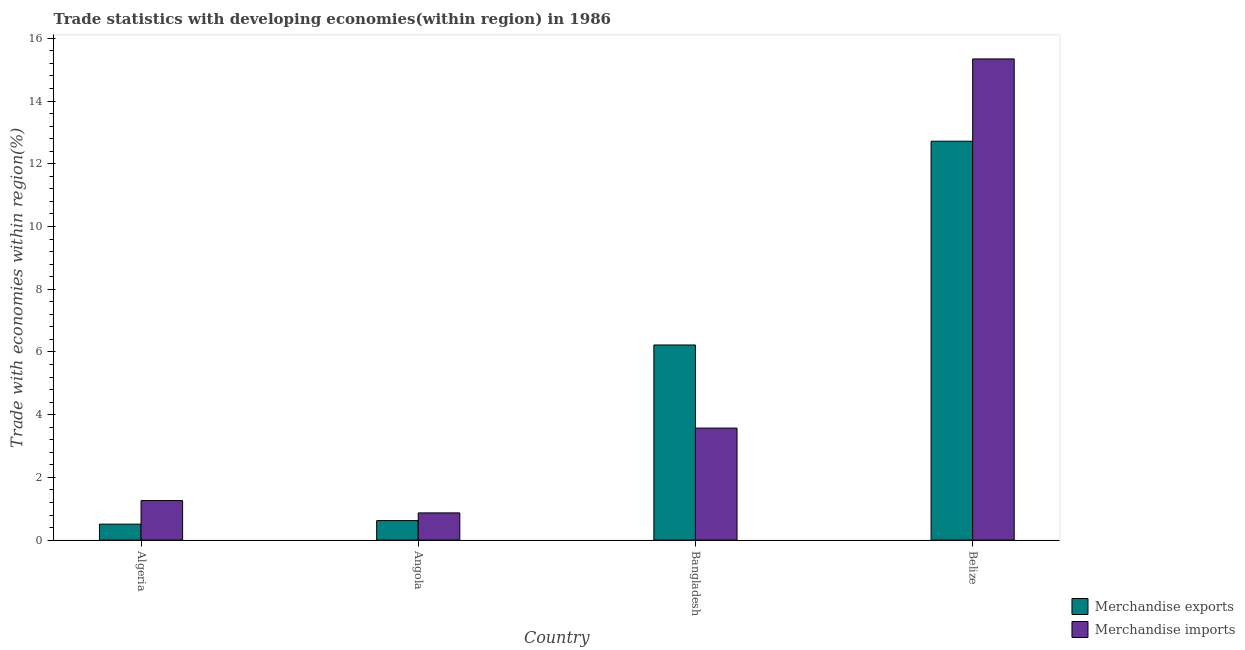How many groups of bars are there?
Give a very brief answer. 4. Are the number of bars per tick equal to the number of legend labels?
Your answer should be compact. Yes. Are the number of bars on each tick of the X-axis equal?
Your answer should be very brief. Yes. How many bars are there on the 2nd tick from the right?
Make the answer very short. 2. What is the merchandise imports in Belize?
Provide a succinct answer. 15.34. Across all countries, what is the maximum merchandise imports?
Your response must be concise. 15.34. Across all countries, what is the minimum merchandise exports?
Your answer should be very brief. 0.51. In which country was the merchandise exports maximum?
Your answer should be very brief. Belize. In which country was the merchandise imports minimum?
Your answer should be compact. Angola. What is the total merchandise exports in the graph?
Offer a terse response. 20.07. What is the difference between the merchandise imports in Angola and that in Bangladesh?
Your answer should be compact. -2.7. What is the difference between the merchandise exports in Angola and the merchandise imports in Algeria?
Provide a succinct answer. -0.64. What is the average merchandise imports per country?
Your response must be concise. 5.26. What is the difference between the merchandise exports and merchandise imports in Algeria?
Your response must be concise. -0.75. In how many countries, is the merchandise exports greater than 7.2 %?
Your response must be concise. 1. What is the ratio of the merchandise imports in Algeria to that in Belize?
Your answer should be compact. 0.08. Is the difference between the merchandise imports in Bangladesh and Belize greater than the difference between the merchandise exports in Bangladesh and Belize?
Offer a very short reply. No. What is the difference between the highest and the second highest merchandise imports?
Your answer should be compact. 11.77. What is the difference between the highest and the lowest merchandise exports?
Your answer should be very brief. 12.21. In how many countries, is the merchandise exports greater than the average merchandise exports taken over all countries?
Ensure brevity in your answer.  2. How many bars are there?
Keep it short and to the point. 8. Does the graph contain grids?
Give a very brief answer. No. How many legend labels are there?
Keep it short and to the point. 2. What is the title of the graph?
Keep it short and to the point. Trade statistics with developing economies(within region) in 1986. Does "Commercial service imports" appear as one of the legend labels in the graph?
Your answer should be compact. No. What is the label or title of the Y-axis?
Your response must be concise. Trade with economies within region(%). What is the Trade with economies within region(%) in Merchandise exports in Algeria?
Keep it short and to the point. 0.51. What is the Trade with economies within region(%) in Merchandise imports in Algeria?
Provide a succinct answer. 1.26. What is the Trade with economies within region(%) of Merchandise exports in Angola?
Provide a short and direct response. 0.62. What is the Trade with economies within region(%) in Merchandise imports in Angola?
Offer a terse response. 0.87. What is the Trade with economies within region(%) in Merchandise exports in Bangladesh?
Provide a short and direct response. 6.22. What is the Trade with economies within region(%) in Merchandise imports in Bangladesh?
Provide a short and direct response. 3.57. What is the Trade with economies within region(%) of Merchandise exports in Belize?
Your response must be concise. 12.72. What is the Trade with economies within region(%) in Merchandise imports in Belize?
Provide a short and direct response. 15.34. Across all countries, what is the maximum Trade with economies within region(%) in Merchandise exports?
Your response must be concise. 12.72. Across all countries, what is the maximum Trade with economies within region(%) in Merchandise imports?
Your answer should be very brief. 15.34. Across all countries, what is the minimum Trade with economies within region(%) of Merchandise exports?
Provide a short and direct response. 0.51. Across all countries, what is the minimum Trade with economies within region(%) of Merchandise imports?
Offer a very short reply. 0.87. What is the total Trade with economies within region(%) in Merchandise exports in the graph?
Your answer should be very brief. 20.07. What is the total Trade with economies within region(%) of Merchandise imports in the graph?
Give a very brief answer. 21.04. What is the difference between the Trade with economies within region(%) in Merchandise exports in Algeria and that in Angola?
Give a very brief answer. -0.11. What is the difference between the Trade with economies within region(%) of Merchandise imports in Algeria and that in Angola?
Keep it short and to the point. 0.39. What is the difference between the Trade with economies within region(%) of Merchandise exports in Algeria and that in Bangladesh?
Ensure brevity in your answer.  -5.71. What is the difference between the Trade with economies within region(%) of Merchandise imports in Algeria and that in Bangladesh?
Provide a succinct answer. -2.31. What is the difference between the Trade with economies within region(%) of Merchandise exports in Algeria and that in Belize?
Give a very brief answer. -12.21. What is the difference between the Trade with economies within region(%) in Merchandise imports in Algeria and that in Belize?
Your answer should be compact. -14.08. What is the difference between the Trade with economies within region(%) in Merchandise exports in Angola and that in Bangladesh?
Provide a short and direct response. -5.6. What is the difference between the Trade with economies within region(%) in Merchandise imports in Angola and that in Bangladesh?
Provide a short and direct response. -2.7. What is the difference between the Trade with economies within region(%) of Merchandise exports in Angola and that in Belize?
Give a very brief answer. -12.1. What is the difference between the Trade with economies within region(%) of Merchandise imports in Angola and that in Belize?
Give a very brief answer. -14.48. What is the difference between the Trade with economies within region(%) in Merchandise exports in Bangladesh and that in Belize?
Give a very brief answer. -6.5. What is the difference between the Trade with economies within region(%) in Merchandise imports in Bangladesh and that in Belize?
Provide a short and direct response. -11.77. What is the difference between the Trade with economies within region(%) of Merchandise exports in Algeria and the Trade with economies within region(%) of Merchandise imports in Angola?
Provide a succinct answer. -0.36. What is the difference between the Trade with economies within region(%) of Merchandise exports in Algeria and the Trade with economies within region(%) of Merchandise imports in Bangladesh?
Offer a very short reply. -3.06. What is the difference between the Trade with economies within region(%) of Merchandise exports in Algeria and the Trade with economies within region(%) of Merchandise imports in Belize?
Keep it short and to the point. -14.84. What is the difference between the Trade with economies within region(%) in Merchandise exports in Angola and the Trade with economies within region(%) in Merchandise imports in Bangladesh?
Your answer should be compact. -2.95. What is the difference between the Trade with economies within region(%) of Merchandise exports in Angola and the Trade with economies within region(%) of Merchandise imports in Belize?
Ensure brevity in your answer.  -14.72. What is the difference between the Trade with economies within region(%) in Merchandise exports in Bangladesh and the Trade with economies within region(%) in Merchandise imports in Belize?
Make the answer very short. -9.12. What is the average Trade with economies within region(%) of Merchandise exports per country?
Give a very brief answer. 5.02. What is the average Trade with economies within region(%) of Merchandise imports per country?
Your answer should be compact. 5.26. What is the difference between the Trade with economies within region(%) of Merchandise exports and Trade with economies within region(%) of Merchandise imports in Algeria?
Your answer should be very brief. -0.75. What is the difference between the Trade with economies within region(%) in Merchandise exports and Trade with economies within region(%) in Merchandise imports in Angola?
Ensure brevity in your answer.  -0.25. What is the difference between the Trade with economies within region(%) of Merchandise exports and Trade with economies within region(%) of Merchandise imports in Bangladesh?
Give a very brief answer. 2.65. What is the difference between the Trade with economies within region(%) of Merchandise exports and Trade with economies within region(%) of Merchandise imports in Belize?
Offer a terse response. -2.62. What is the ratio of the Trade with economies within region(%) of Merchandise exports in Algeria to that in Angola?
Offer a terse response. 0.82. What is the ratio of the Trade with economies within region(%) in Merchandise imports in Algeria to that in Angola?
Provide a succinct answer. 1.45. What is the ratio of the Trade with economies within region(%) of Merchandise exports in Algeria to that in Bangladesh?
Provide a succinct answer. 0.08. What is the ratio of the Trade with economies within region(%) in Merchandise imports in Algeria to that in Bangladesh?
Provide a succinct answer. 0.35. What is the ratio of the Trade with economies within region(%) in Merchandise imports in Algeria to that in Belize?
Offer a terse response. 0.08. What is the ratio of the Trade with economies within region(%) in Merchandise exports in Angola to that in Bangladesh?
Provide a succinct answer. 0.1. What is the ratio of the Trade with economies within region(%) of Merchandise imports in Angola to that in Bangladesh?
Provide a succinct answer. 0.24. What is the ratio of the Trade with economies within region(%) of Merchandise exports in Angola to that in Belize?
Your response must be concise. 0.05. What is the ratio of the Trade with economies within region(%) in Merchandise imports in Angola to that in Belize?
Ensure brevity in your answer.  0.06. What is the ratio of the Trade with economies within region(%) in Merchandise exports in Bangladesh to that in Belize?
Give a very brief answer. 0.49. What is the ratio of the Trade with economies within region(%) in Merchandise imports in Bangladesh to that in Belize?
Your answer should be compact. 0.23. What is the difference between the highest and the second highest Trade with economies within region(%) of Merchandise exports?
Offer a very short reply. 6.5. What is the difference between the highest and the second highest Trade with economies within region(%) in Merchandise imports?
Provide a succinct answer. 11.77. What is the difference between the highest and the lowest Trade with economies within region(%) of Merchandise exports?
Provide a short and direct response. 12.21. What is the difference between the highest and the lowest Trade with economies within region(%) of Merchandise imports?
Keep it short and to the point. 14.48. 